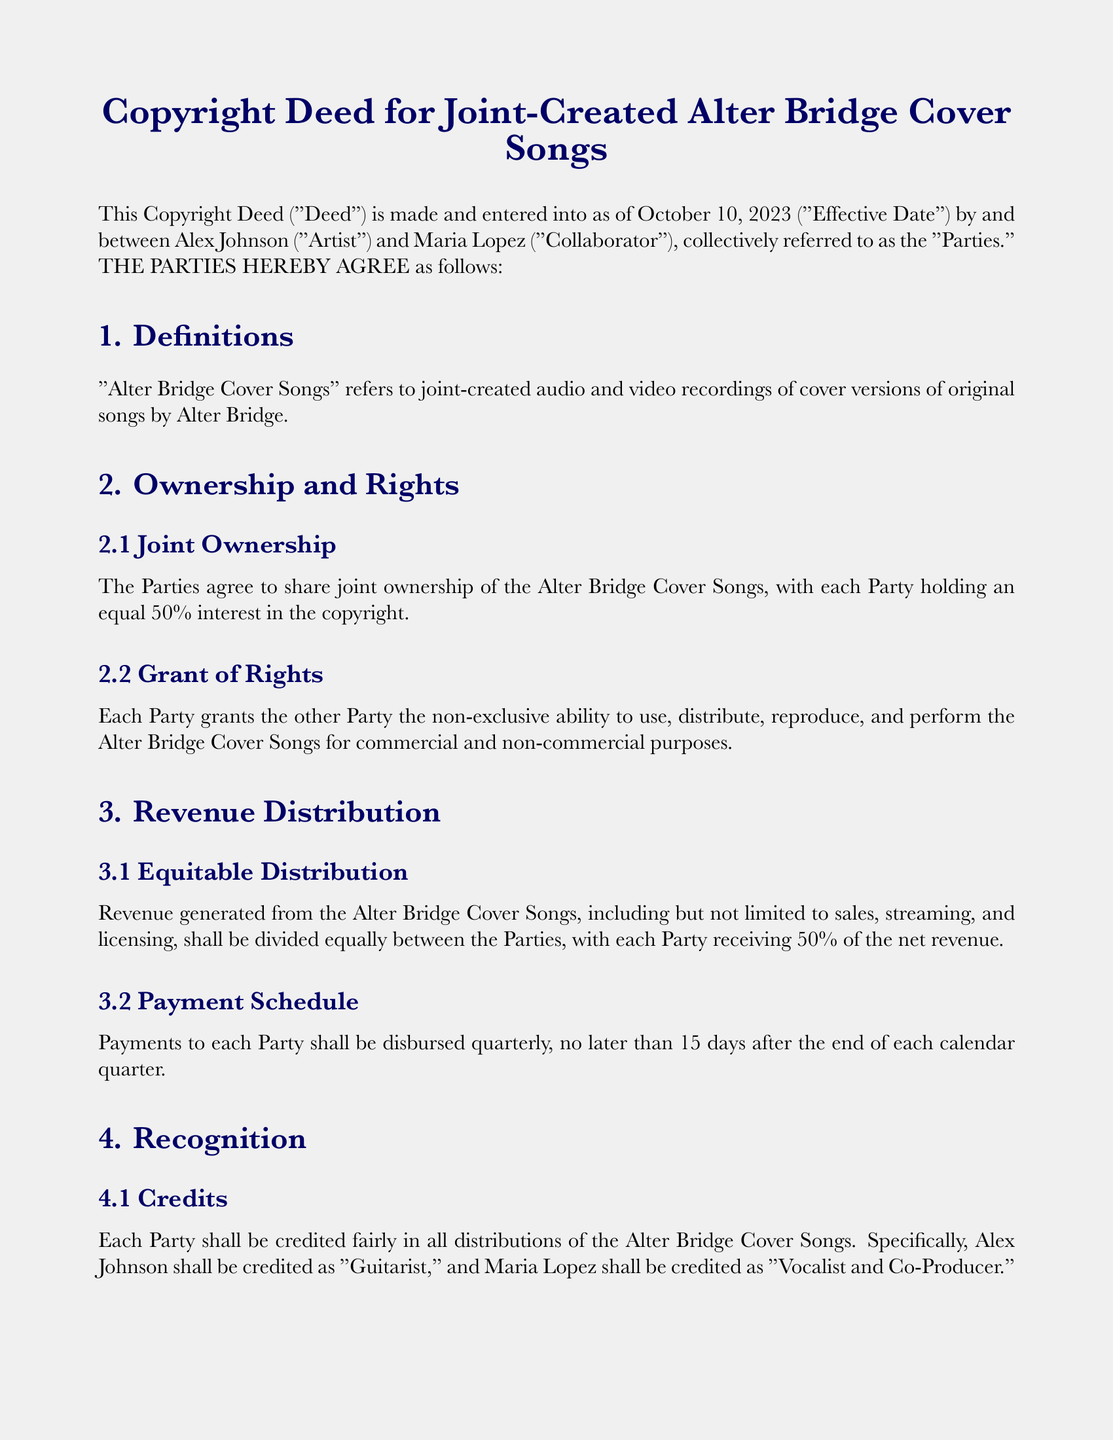What is the effective date of the Deed? The effective date is mentioned in the introduction of the document as the date when the agreement becomes valid.
Answer: October 10, 2023 Who holds the joint ownership of the Alter Bridge Cover Songs? The joint ownership is specified in the ownership section, detailing who has rights over the created works.
Answer: Alex Johnson and Maria Lopez What percentage of net revenue does each Party receive? The revenue distribution section specifies the equal sharing of revenue between the Parties.
Answer: 50% What title is Alex Johnson credited with? The credits section outlines how each Party is recognized in the distribution of the cover songs.
Answer: Guitarist What must Parties agree on to make amendments to the Deed? The miscellaneous section defines how modifications to the agreement should take place.
Answer: In writing What is the first step in resolving disputes according to the document? The dispute resolution section indicates the preferred initial approach to handle disagreements between the Parties.
Answer: Negotiation How often are payments disbursed to each Party? The payment schedule clarifies how frequently payments are made to the involved Parties.
Answer: Quarterly Which state's laws govern this Deed? The governing law section specifies the jurisdiction under which the Deed is interpreted and enforced.
Answer: California 